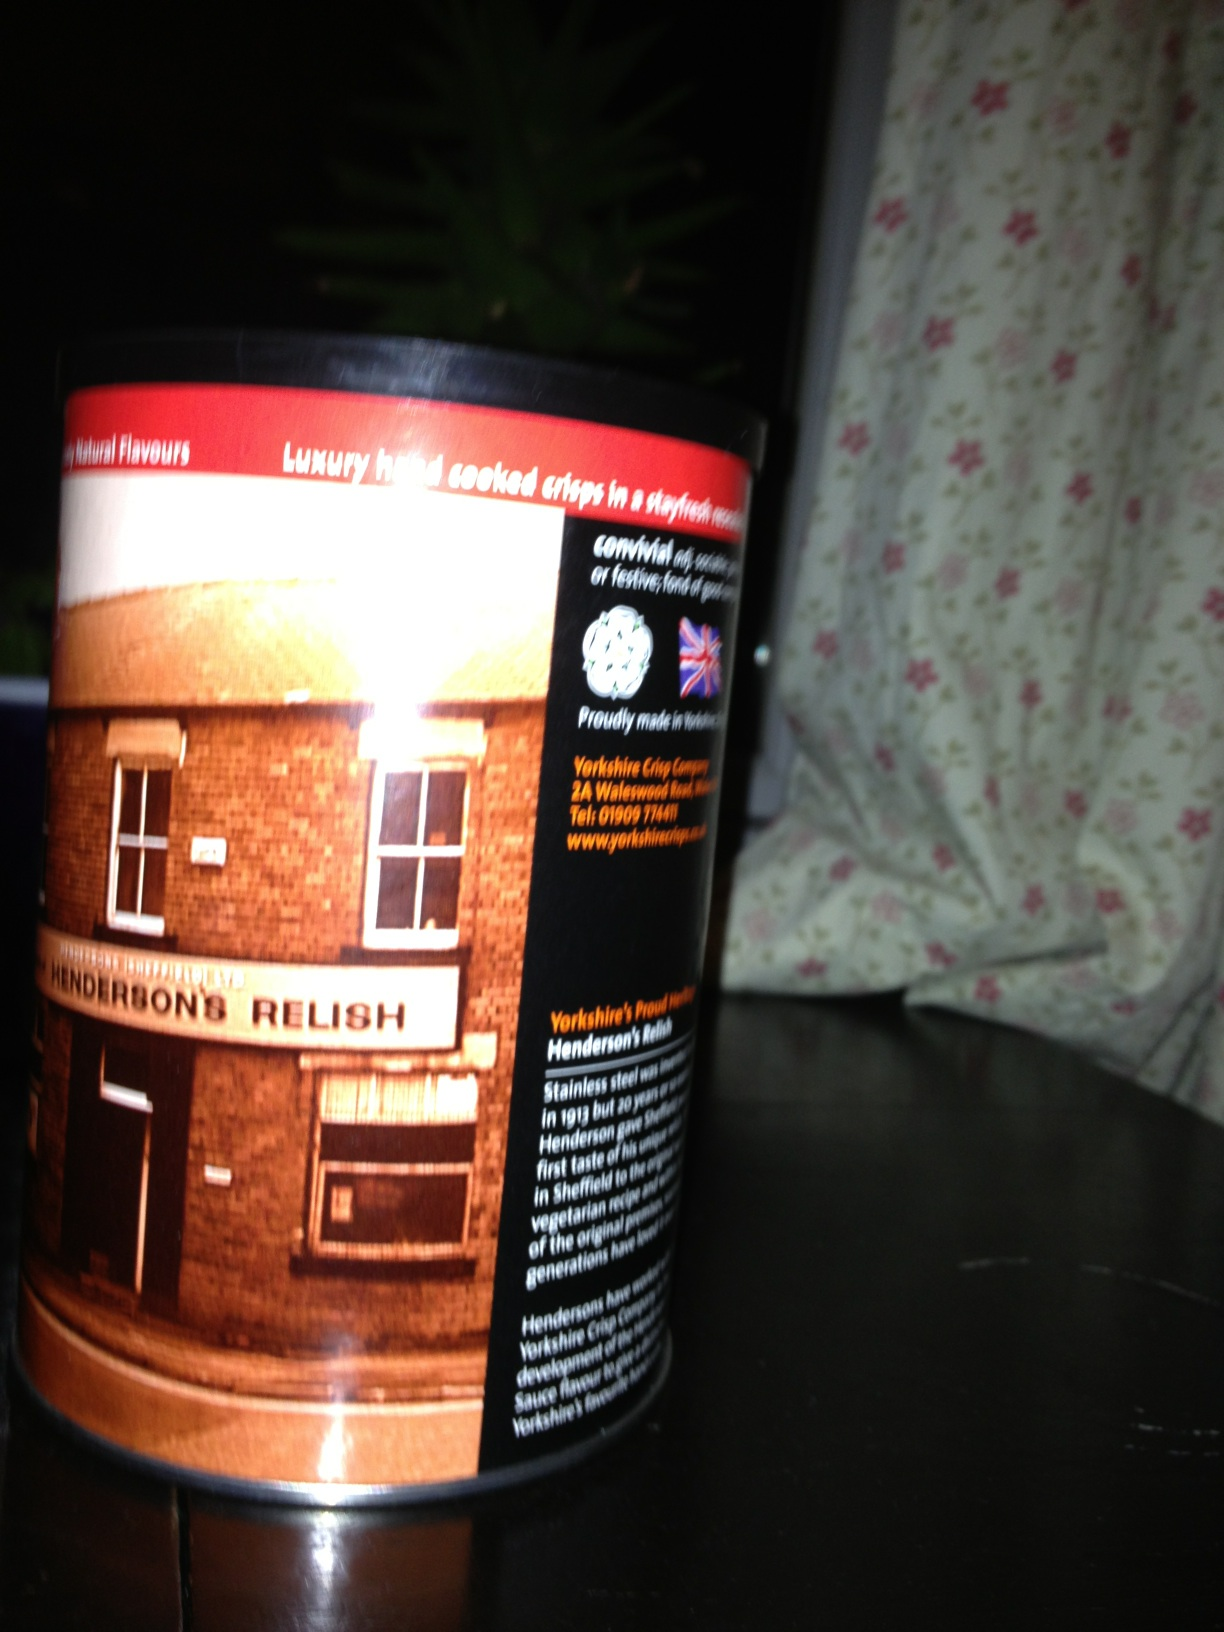How is Henderson's Relish environmentally sustainable? Henderson's Relish is committed to environmental sustainability through several key practices. The company sources its ingredients from local farmers and suppliers whenever possible, reducing its carbon footprint and supporting the local economy. The production process prioritizes energy efficiency and waste minimization. Additionally, the packaging is designed to be recyclable, with the use of sustainable materials whenever feasible. This commitment ensures that while Henderson's Relish continues to deliver its distinctive flavor, it also plays a part in preserving the environment. 